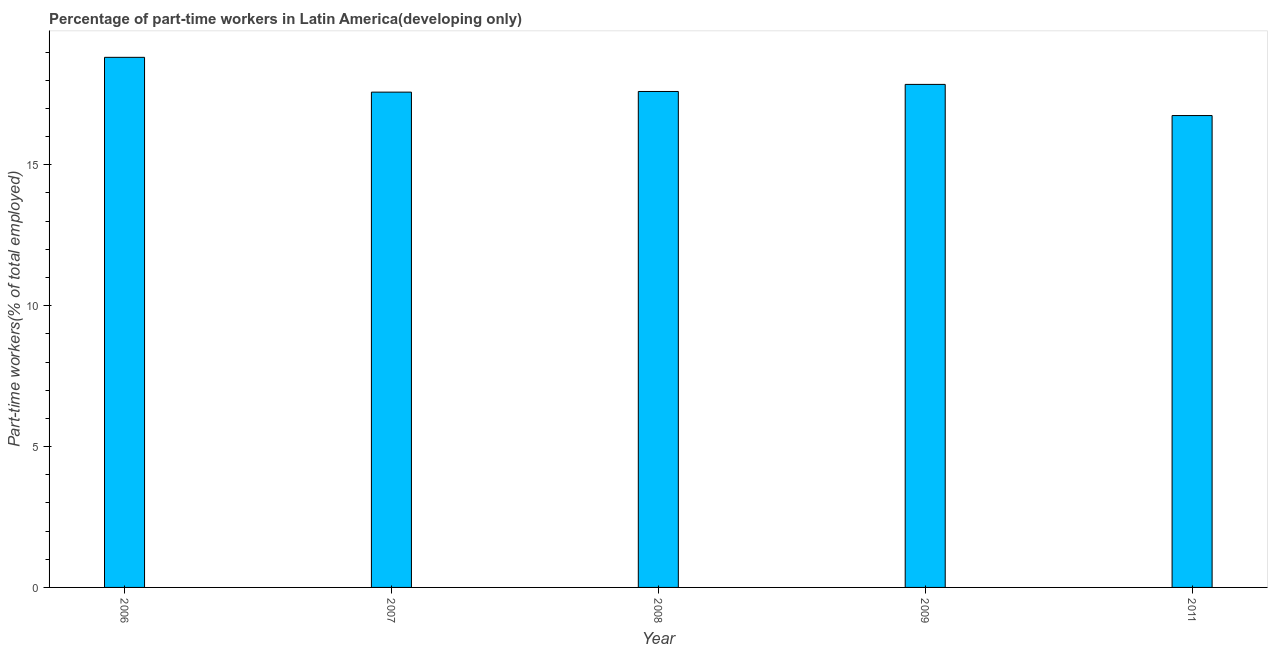Does the graph contain any zero values?
Your response must be concise. No. What is the title of the graph?
Make the answer very short. Percentage of part-time workers in Latin America(developing only). What is the label or title of the X-axis?
Your response must be concise. Year. What is the label or title of the Y-axis?
Your response must be concise. Part-time workers(% of total employed). What is the percentage of part-time workers in 2006?
Your response must be concise. 18.81. Across all years, what is the maximum percentage of part-time workers?
Give a very brief answer. 18.81. Across all years, what is the minimum percentage of part-time workers?
Your response must be concise. 16.75. What is the sum of the percentage of part-time workers?
Ensure brevity in your answer.  88.6. What is the difference between the percentage of part-time workers in 2006 and 2007?
Offer a very short reply. 1.24. What is the average percentage of part-time workers per year?
Provide a succinct answer. 17.72. What is the median percentage of part-time workers?
Make the answer very short. 17.6. Do a majority of the years between 2009 and 2006 (inclusive) have percentage of part-time workers greater than 8 %?
Offer a terse response. Yes. What is the ratio of the percentage of part-time workers in 2009 to that in 2011?
Your answer should be very brief. 1.07. Is the difference between the percentage of part-time workers in 2006 and 2007 greater than the difference between any two years?
Keep it short and to the point. No. Is the sum of the percentage of part-time workers in 2007 and 2008 greater than the maximum percentage of part-time workers across all years?
Offer a very short reply. Yes. What is the difference between the highest and the lowest percentage of part-time workers?
Your answer should be compact. 2.07. In how many years, is the percentage of part-time workers greater than the average percentage of part-time workers taken over all years?
Keep it short and to the point. 2. Are all the bars in the graph horizontal?
Your answer should be compact. No. How many years are there in the graph?
Make the answer very short. 5. What is the difference between two consecutive major ticks on the Y-axis?
Give a very brief answer. 5. What is the Part-time workers(% of total employed) of 2006?
Offer a terse response. 18.81. What is the Part-time workers(% of total employed) of 2007?
Give a very brief answer. 17.58. What is the Part-time workers(% of total employed) in 2008?
Provide a succinct answer. 17.6. What is the Part-time workers(% of total employed) of 2009?
Provide a short and direct response. 17.85. What is the Part-time workers(% of total employed) of 2011?
Offer a very short reply. 16.75. What is the difference between the Part-time workers(% of total employed) in 2006 and 2007?
Keep it short and to the point. 1.24. What is the difference between the Part-time workers(% of total employed) in 2006 and 2008?
Offer a terse response. 1.21. What is the difference between the Part-time workers(% of total employed) in 2006 and 2009?
Your answer should be compact. 0.96. What is the difference between the Part-time workers(% of total employed) in 2006 and 2011?
Ensure brevity in your answer.  2.07. What is the difference between the Part-time workers(% of total employed) in 2007 and 2008?
Your answer should be very brief. -0.02. What is the difference between the Part-time workers(% of total employed) in 2007 and 2009?
Give a very brief answer. -0.27. What is the difference between the Part-time workers(% of total employed) in 2007 and 2011?
Keep it short and to the point. 0.83. What is the difference between the Part-time workers(% of total employed) in 2008 and 2009?
Your response must be concise. -0.25. What is the difference between the Part-time workers(% of total employed) in 2008 and 2011?
Make the answer very short. 0.85. What is the difference between the Part-time workers(% of total employed) in 2009 and 2011?
Your answer should be compact. 1.11. What is the ratio of the Part-time workers(% of total employed) in 2006 to that in 2007?
Your answer should be very brief. 1.07. What is the ratio of the Part-time workers(% of total employed) in 2006 to that in 2008?
Your answer should be compact. 1.07. What is the ratio of the Part-time workers(% of total employed) in 2006 to that in 2009?
Offer a terse response. 1.05. What is the ratio of the Part-time workers(% of total employed) in 2006 to that in 2011?
Make the answer very short. 1.12. What is the ratio of the Part-time workers(% of total employed) in 2007 to that in 2009?
Provide a succinct answer. 0.98. What is the ratio of the Part-time workers(% of total employed) in 2008 to that in 2009?
Your answer should be very brief. 0.99. What is the ratio of the Part-time workers(% of total employed) in 2008 to that in 2011?
Provide a short and direct response. 1.05. What is the ratio of the Part-time workers(% of total employed) in 2009 to that in 2011?
Keep it short and to the point. 1.07. 